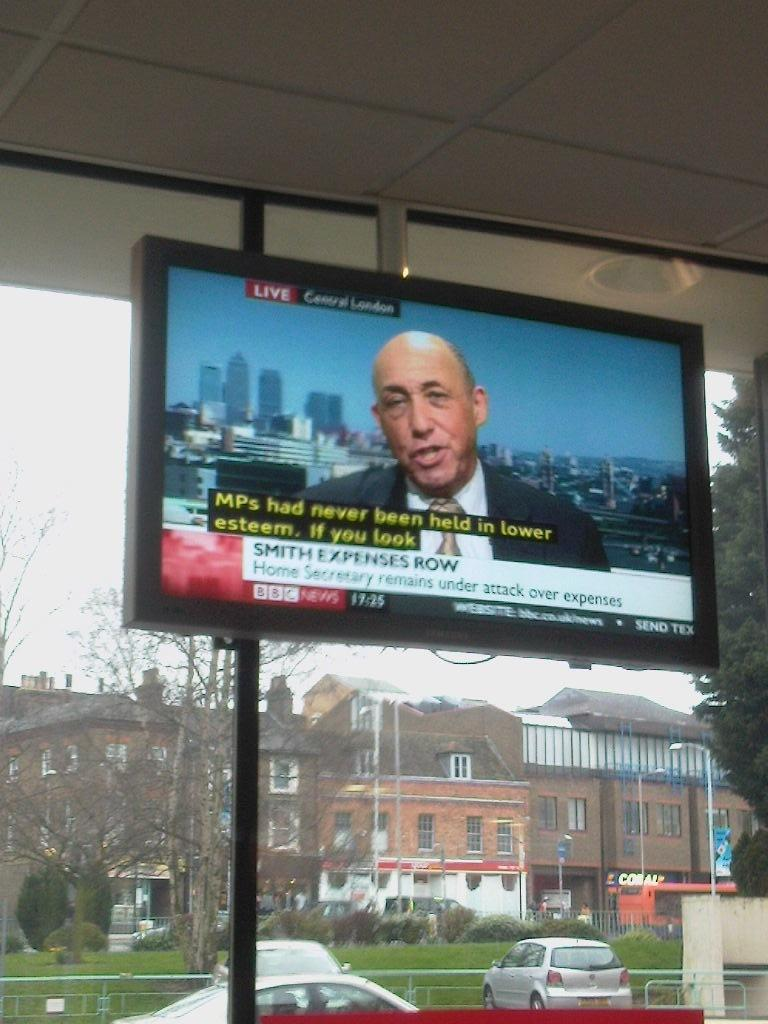<image>
Write a terse but informative summary of the picture. Live Central London broadcasting new about the Home Secretary being under attack for his expenses. 